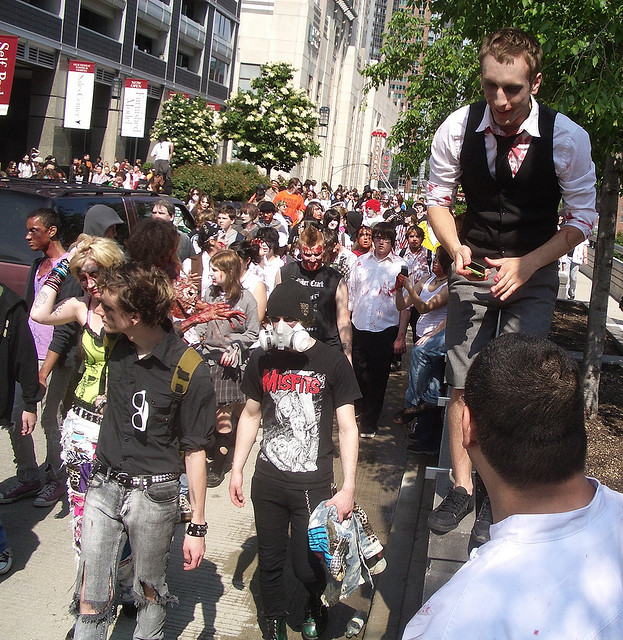<image>What band is on the t-shirt of the guy closest to the camera? I am not sure what band is on the t-shirt of the guy closest to the camera. It might be misfits. What band is on the t-shirt of the guy closest to the camera? I am not sure what band is on the t-shirt of the guy closest to the camera. But it can be seen 'misfits'. 